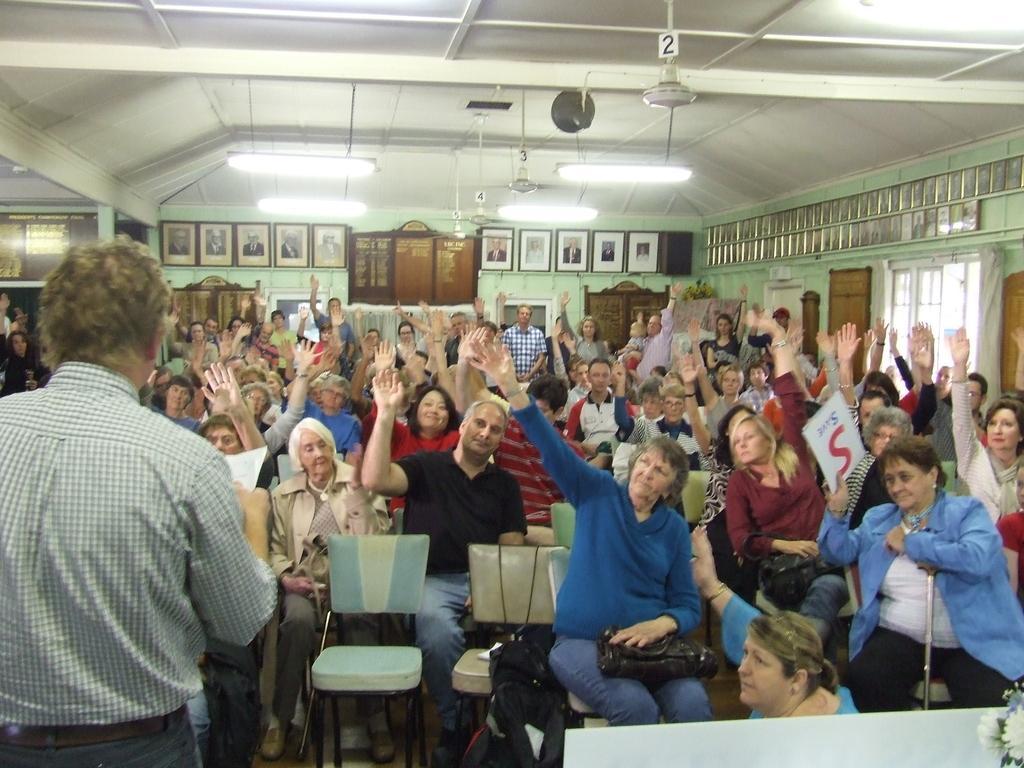Please provide a concise description of this image. This picture shows a group of people seated on the chairs and we see a man standing and holding a paper in his hand and we see few photo frames on the wall 